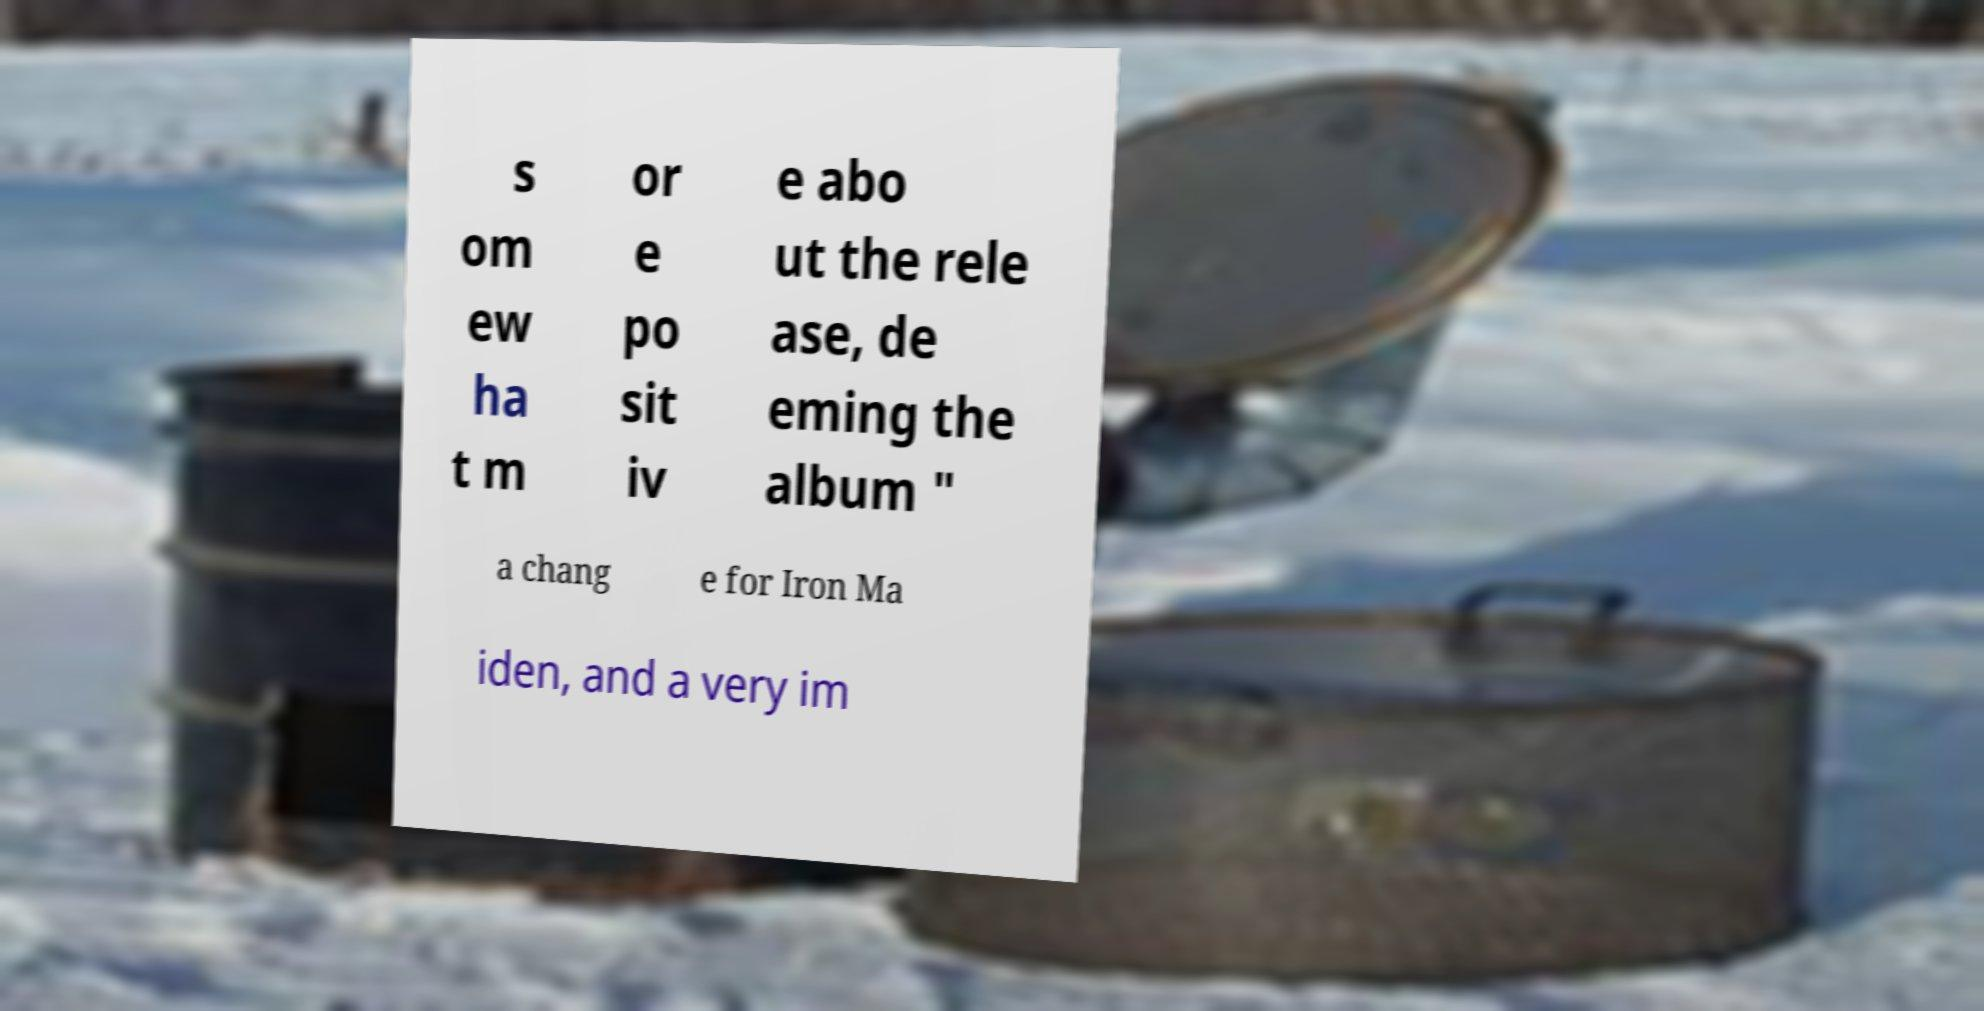For documentation purposes, I need the text within this image transcribed. Could you provide that? s om ew ha t m or e po sit iv e abo ut the rele ase, de eming the album " a chang e for Iron Ma iden, and a very im 